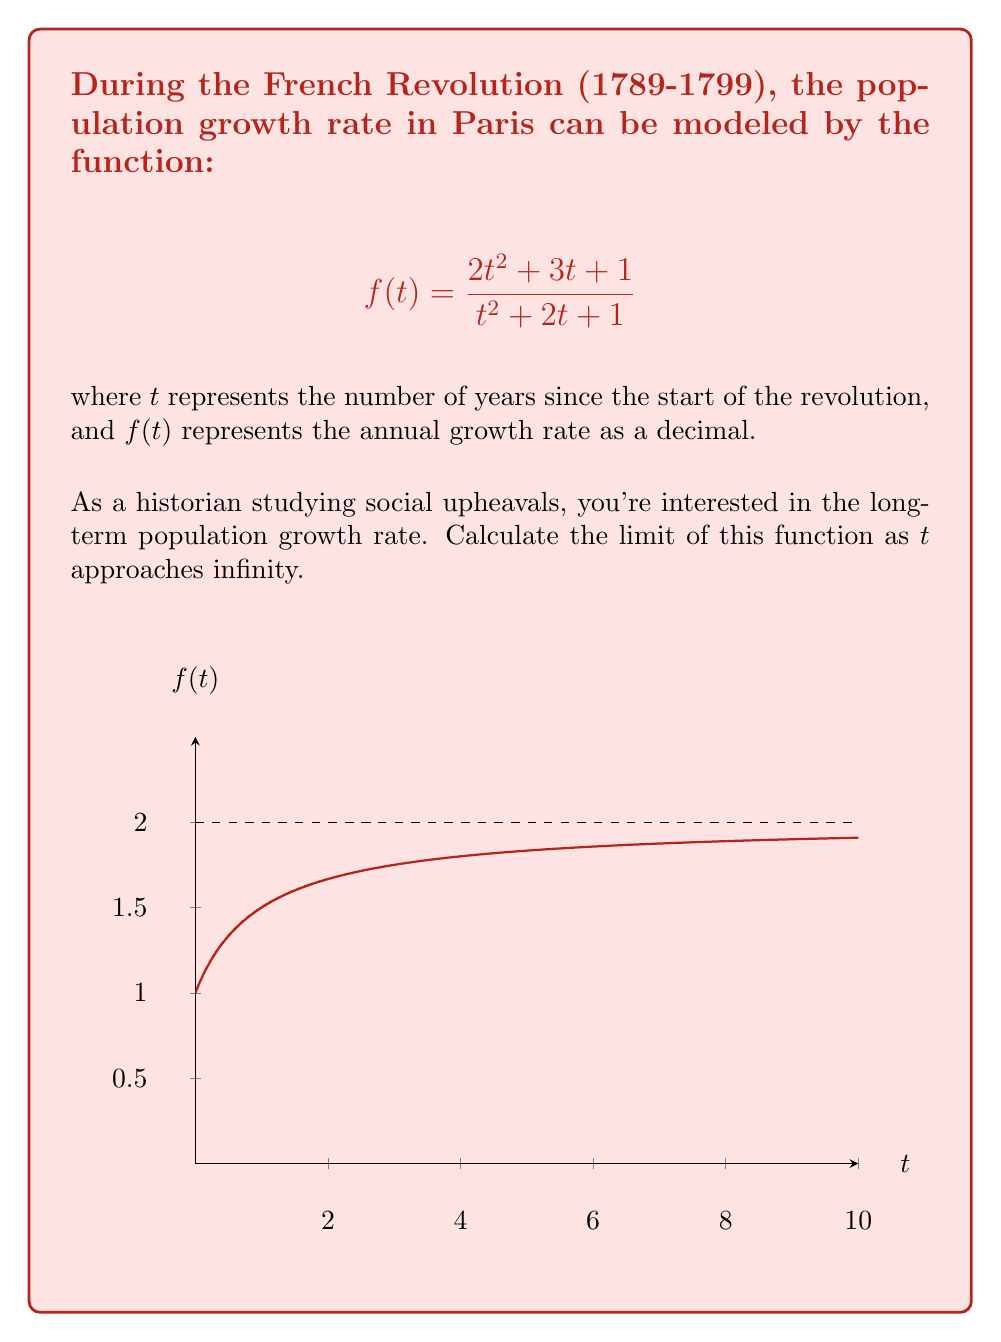Show me your answer to this math problem. To find the limit of $f(t)$ as $t$ approaches infinity, we'll follow these steps:

1) First, let's examine the highest degree terms in the numerator and denominator:
   $$\lim_{t \to \infty} f(t) = \lim_{t \to \infty} \frac{2t^2 + 3t + 1}{t^2 + 2t + 1}$$

2) As $t$ approaches infinity, the highest degree terms ($2t^2$ in the numerator and $t^2$ in the denominator) will dominate:
   $$\lim_{t \to \infty} \frac{2t^2 + 3t + 1}{t^2 + 2t + 1} = \lim_{t \to \infty} \frac{2t^2}{t^2}$$

3) We can simplify this:
   $$\lim_{t \to \infty} \frac{2t^2}{t^2} = \lim_{t \to \infty} 2$$

4) The limit of a constant is the constant itself:
   $$\lim_{t \to \infty} 2 = 2$$

Therefore, the long-term population growth rate approaches 2, or 200% annually, as time goes to infinity.

This result suggests that if this model held true indefinitely (which is unrealistic in practice), the population growth rate in Paris would stabilize at 200% per year in the long run following the French Revolution.
Answer: 2 